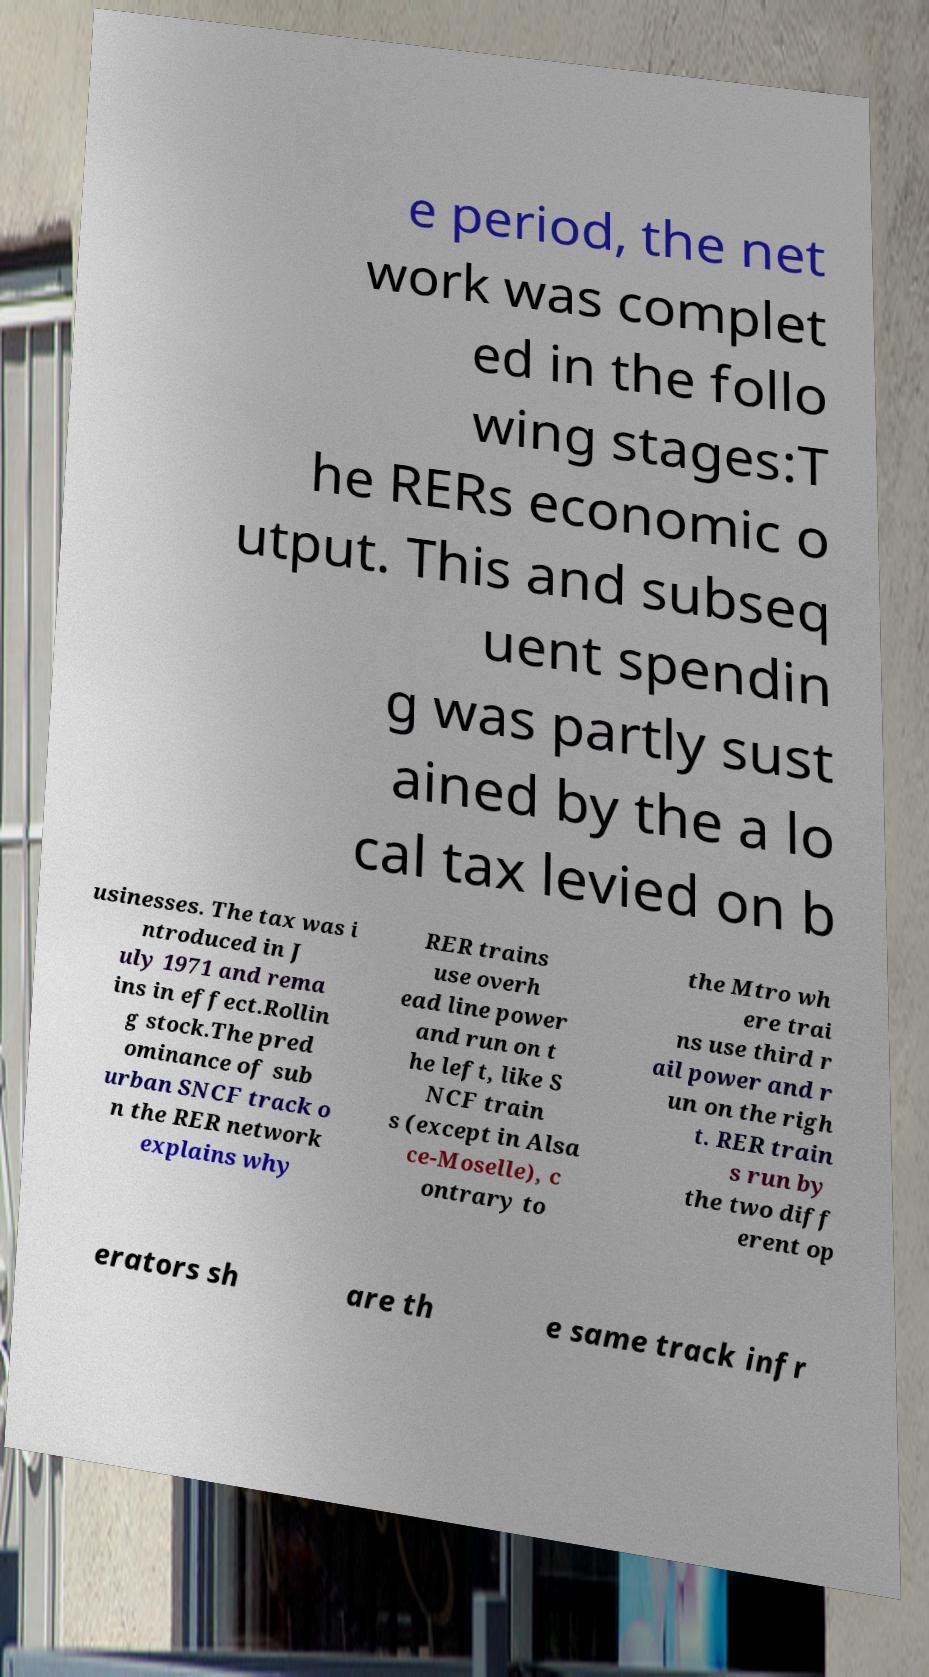For documentation purposes, I need the text within this image transcribed. Could you provide that? e period, the net work was complet ed in the follo wing stages:T he RERs economic o utput. This and subseq uent spendin g was partly sust ained by the a lo cal tax levied on b usinesses. The tax was i ntroduced in J uly 1971 and rema ins in effect.Rollin g stock.The pred ominance of sub urban SNCF track o n the RER network explains why RER trains use overh ead line power and run on t he left, like S NCF train s (except in Alsa ce-Moselle), c ontrary to the Mtro wh ere trai ns use third r ail power and r un on the righ t. RER train s run by the two diff erent op erators sh are th e same track infr 